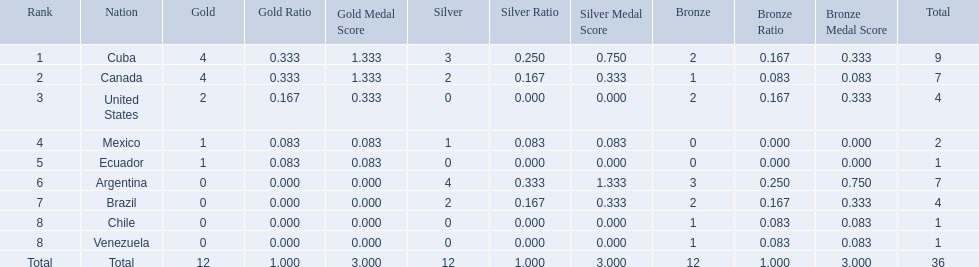Which nations won gold medals? Cuba, Canada, United States, Mexico, Ecuador. How many medals did each nation win? Cuba, 9, Canada, 7, United States, 4, Mexico, 2, Ecuador, 1. Which nation only won a gold medal? Ecuador. 